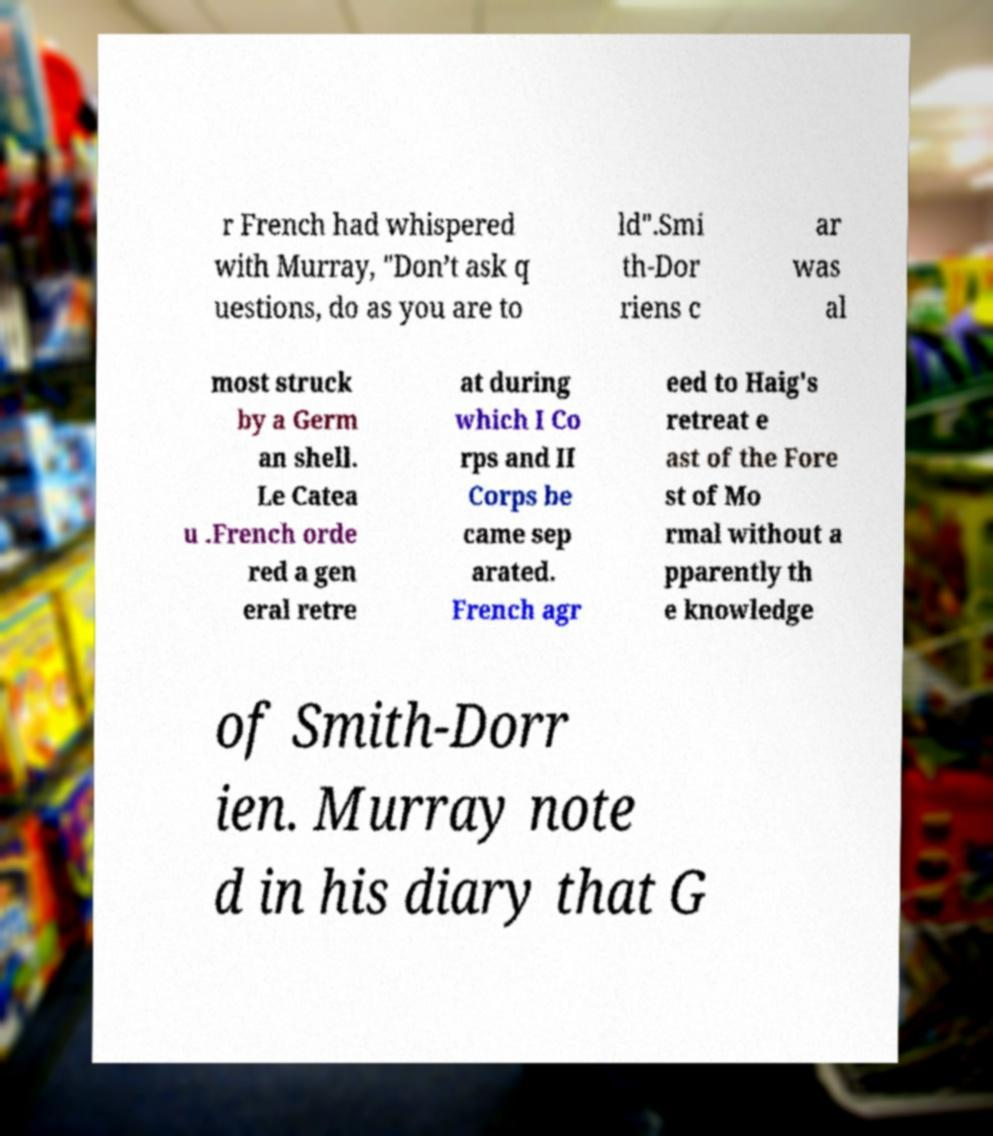Can you accurately transcribe the text from the provided image for me? r French had whispered with Murray, "Don’t ask q uestions, do as you are to ld".Smi th-Dor riens c ar was al most struck by a Germ an shell. Le Catea u .French orde red a gen eral retre at during which I Co rps and II Corps be came sep arated. French agr eed to Haig's retreat e ast of the Fore st of Mo rmal without a pparently th e knowledge of Smith-Dorr ien. Murray note d in his diary that G 